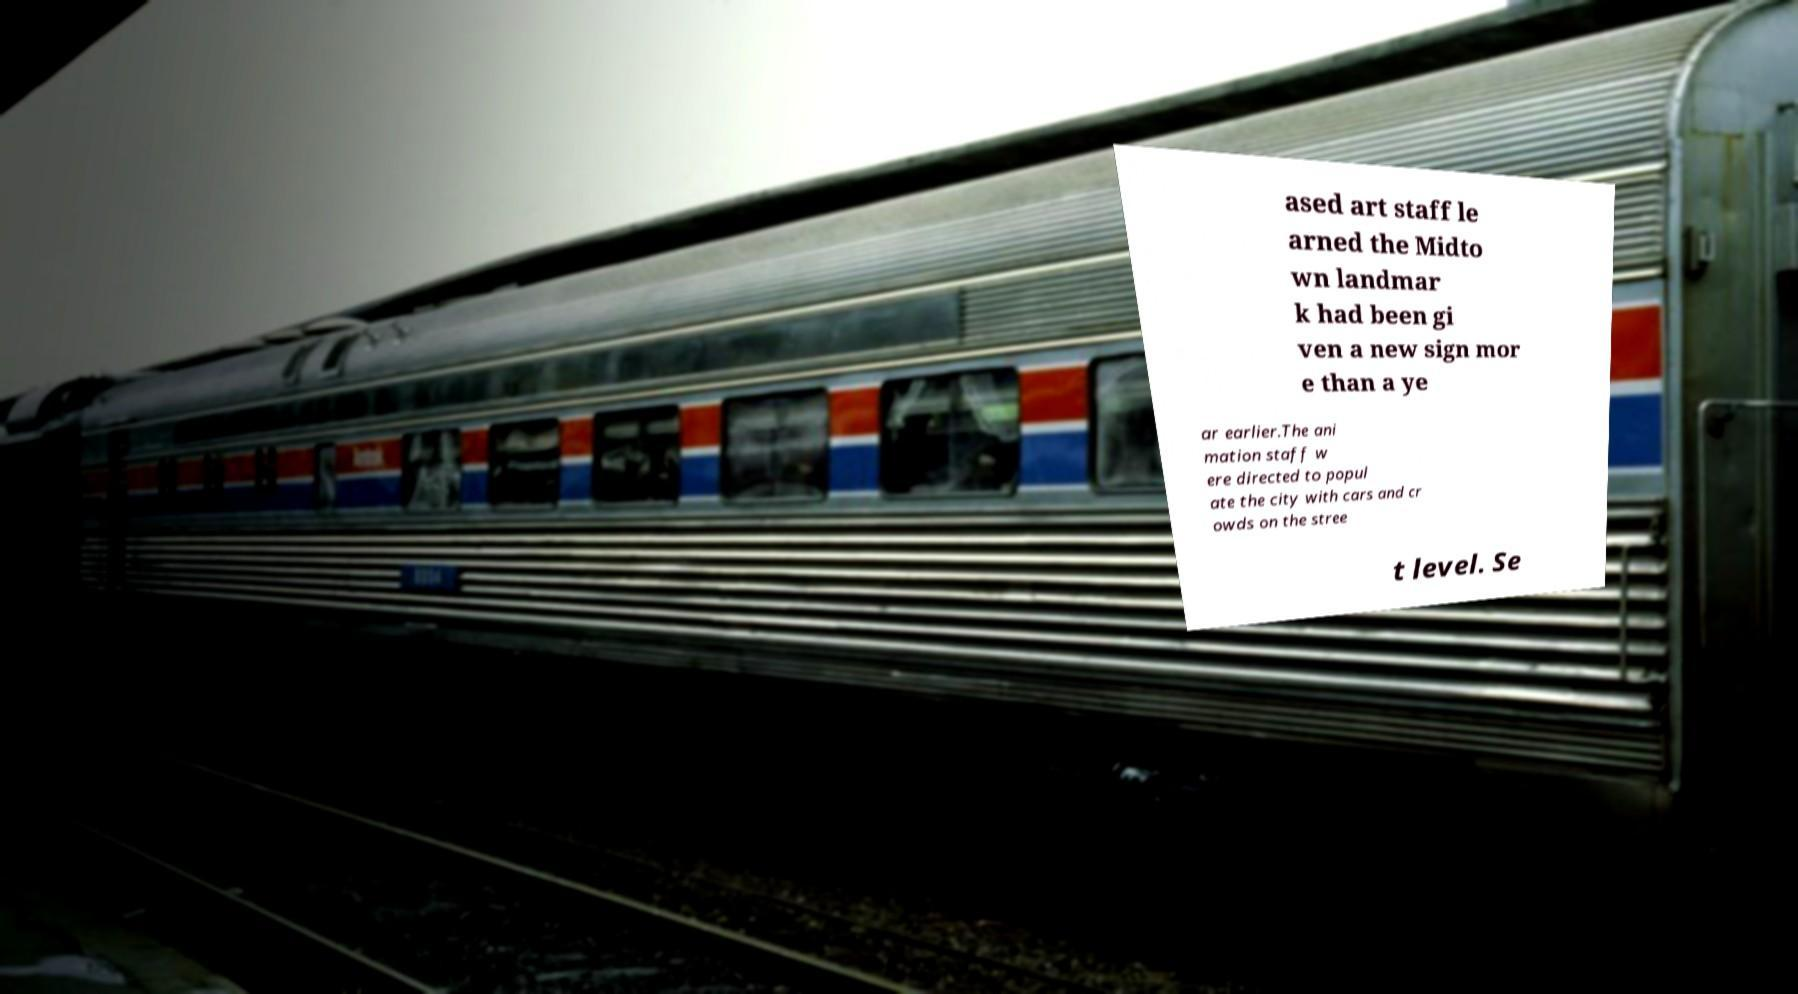What messages or text are displayed in this image? I need them in a readable, typed format. ased art staff le arned the Midto wn landmar k had been gi ven a new sign mor e than a ye ar earlier.The ani mation staff w ere directed to popul ate the city with cars and cr owds on the stree t level. Se 